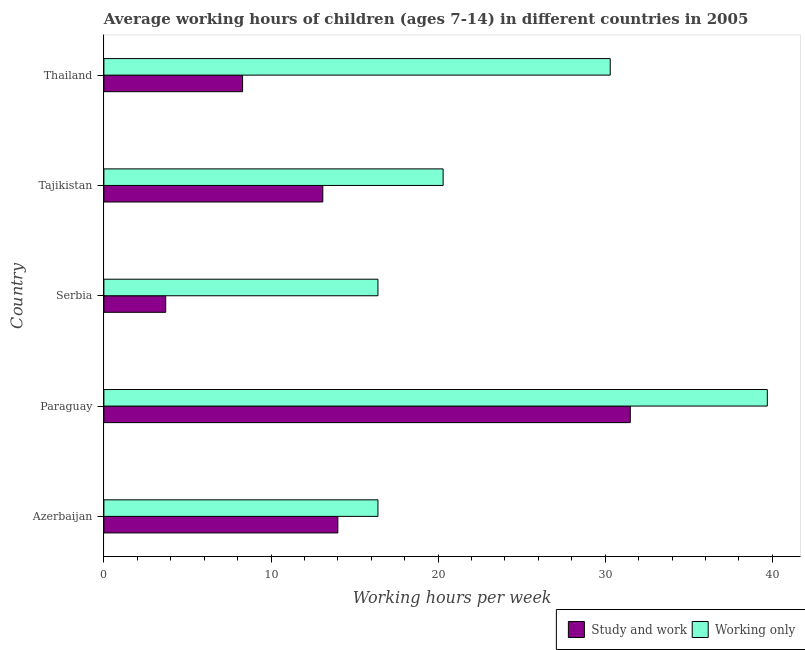How many different coloured bars are there?
Your answer should be compact. 2. Are the number of bars on each tick of the Y-axis equal?
Give a very brief answer. Yes. What is the label of the 4th group of bars from the top?
Provide a short and direct response. Paraguay. In how many cases, is the number of bars for a given country not equal to the number of legend labels?
Ensure brevity in your answer.  0. What is the average working hour of children involved in only work in Thailand?
Offer a very short reply. 30.3. Across all countries, what is the maximum average working hour of children involved in only work?
Make the answer very short. 39.7. In which country was the average working hour of children involved in study and work maximum?
Ensure brevity in your answer.  Paraguay. In which country was the average working hour of children involved in only work minimum?
Offer a terse response. Azerbaijan. What is the total average working hour of children involved in only work in the graph?
Keep it short and to the point. 123.1. What is the difference between the average working hour of children involved in only work in Paraguay and the average working hour of children involved in study and work in Tajikistan?
Make the answer very short. 26.6. What is the average average working hour of children involved in study and work per country?
Ensure brevity in your answer.  14.12. What is the ratio of the average working hour of children involved in study and work in Azerbaijan to that in Tajikistan?
Your response must be concise. 1.07. Is the average working hour of children involved in study and work in Serbia less than that in Tajikistan?
Ensure brevity in your answer.  Yes. Is the difference between the average working hour of children involved in study and work in Paraguay and Thailand greater than the difference between the average working hour of children involved in only work in Paraguay and Thailand?
Your answer should be compact. Yes. What is the difference between the highest and the second highest average working hour of children involved in study and work?
Offer a terse response. 17.5. What is the difference between the highest and the lowest average working hour of children involved in only work?
Offer a very short reply. 23.3. In how many countries, is the average working hour of children involved in study and work greater than the average average working hour of children involved in study and work taken over all countries?
Provide a succinct answer. 1. What does the 1st bar from the top in Azerbaijan represents?
Offer a very short reply. Working only. What does the 1st bar from the bottom in Paraguay represents?
Provide a short and direct response. Study and work. Are all the bars in the graph horizontal?
Provide a short and direct response. Yes. What is the difference between two consecutive major ticks on the X-axis?
Ensure brevity in your answer.  10. Are the values on the major ticks of X-axis written in scientific E-notation?
Your response must be concise. No. Does the graph contain any zero values?
Provide a succinct answer. No. How many legend labels are there?
Keep it short and to the point. 2. How are the legend labels stacked?
Your answer should be very brief. Horizontal. What is the title of the graph?
Offer a terse response. Average working hours of children (ages 7-14) in different countries in 2005. What is the label or title of the X-axis?
Offer a terse response. Working hours per week. What is the label or title of the Y-axis?
Your response must be concise. Country. What is the Working hours per week of Study and work in Azerbaijan?
Offer a terse response. 14. What is the Working hours per week of Working only in Azerbaijan?
Make the answer very short. 16.4. What is the Working hours per week of Study and work in Paraguay?
Give a very brief answer. 31.5. What is the Working hours per week in Working only in Paraguay?
Make the answer very short. 39.7. What is the Working hours per week in Study and work in Tajikistan?
Your response must be concise. 13.1. What is the Working hours per week in Working only in Tajikistan?
Provide a succinct answer. 20.3. What is the Working hours per week of Working only in Thailand?
Your answer should be compact. 30.3. Across all countries, what is the maximum Working hours per week in Study and work?
Your answer should be compact. 31.5. Across all countries, what is the maximum Working hours per week of Working only?
Offer a terse response. 39.7. Across all countries, what is the minimum Working hours per week in Study and work?
Your answer should be very brief. 3.7. What is the total Working hours per week in Study and work in the graph?
Your response must be concise. 70.6. What is the total Working hours per week of Working only in the graph?
Provide a succinct answer. 123.1. What is the difference between the Working hours per week of Study and work in Azerbaijan and that in Paraguay?
Provide a succinct answer. -17.5. What is the difference between the Working hours per week in Working only in Azerbaijan and that in Paraguay?
Your response must be concise. -23.3. What is the difference between the Working hours per week in Working only in Azerbaijan and that in Serbia?
Your response must be concise. 0. What is the difference between the Working hours per week in Working only in Azerbaijan and that in Tajikistan?
Provide a short and direct response. -3.9. What is the difference between the Working hours per week in Study and work in Paraguay and that in Serbia?
Your response must be concise. 27.8. What is the difference between the Working hours per week in Working only in Paraguay and that in Serbia?
Your answer should be compact. 23.3. What is the difference between the Working hours per week of Working only in Paraguay and that in Tajikistan?
Your response must be concise. 19.4. What is the difference between the Working hours per week of Study and work in Paraguay and that in Thailand?
Keep it short and to the point. 23.2. What is the difference between the Working hours per week of Working only in Paraguay and that in Thailand?
Your answer should be compact. 9.4. What is the difference between the Working hours per week of Working only in Serbia and that in Tajikistan?
Provide a short and direct response. -3.9. What is the difference between the Working hours per week of Working only in Serbia and that in Thailand?
Your answer should be compact. -13.9. What is the difference between the Working hours per week in Study and work in Tajikistan and that in Thailand?
Provide a succinct answer. 4.8. What is the difference between the Working hours per week of Working only in Tajikistan and that in Thailand?
Offer a terse response. -10. What is the difference between the Working hours per week in Study and work in Azerbaijan and the Working hours per week in Working only in Paraguay?
Make the answer very short. -25.7. What is the difference between the Working hours per week in Study and work in Azerbaijan and the Working hours per week in Working only in Tajikistan?
Give a very brief answer. -6.3. What is the difference between the Working hours per week in Study and work in Azerbaijan and the Working hours per week in Working only in Thailand?
Give a very brief answer. -16.3. What is the difference between the Working hours per week of Study and work in Serbia and the Working hours per week of Working only in Tajikistan?
Give a very brief answer. -16.6. What is the difference between the Working hours per week of Study and work in Serbia and the Working hours per week of Working only in Thailand?
Your answer should be compact. -26.6. What is the difference between the Working hours per week of Study and work in Tajikistan and the Working hours per week of Working only in Thailand?
Keep it short and to the point. -17.2. What is the average Working hours per week in Study and work per country?
Provide a succinct answer. 14.12. What is the average Working hours per week in Working only per country?
Provide a short and direct response. 24.62. What is the ratio of the Working hours per week of Study and work in Azerbaijan to that in Paraguay?
Keep it short and to the point. 0.44. What is the ratio of the Working hours per week of Working only in Azerbaijan to that in Paraguay?
Your response must be concise. 0.41. What is the ratio of the Working hours per week of Study and work in Azerbaijan to that in Serbia?
Your response must be concise. 3.78. What is the ratio of the Working hours per week in Study and work in Azerbaijan to that in Tajikistan?
Keep it short and to the point. 1.07. What is the ratio of the Working hours per week in Working only in Azerbaijan to that in Tajikistan?
Keep it short and to the point. 0.81. What is the ratio of the Working hours per week of Study and work in Azerbaijan to that in Thailand?
Your answer should be very brief. 1.69. What is the ratio of the Working hours per week of Working only in Azerbaijan to that in Thailand?
Provide a short and direct response. 0.54. What is the ratio of the Working hours per week in Study and work in Paraguay to that in Serbia?
Your response must be concise. 8.51. What is the ratio of the Working hours per week in Working only in Paraguay to that in Serbia?
Ensure brevity in your answer.  2.42. What is the ratio of the Working hours per week of Study and work in Paraguay to that in Tajikistan?
Your response must be concise. 2.4. What is the ratio of the Working hours per week in Working only in Paraguay to that in Tajikistan?
Ensure brevity in your answer.  1.96. What is the ratio of the Working hours per week of Study and work in Paraguay to that in Thailand?
Your response must be concise. 3.8. What is the ratio of the Working hours per week of Working only in Paraguay to that in Thailand?
Ensure brevity in your answer.  1.31. What is the ratio of the Working hours per week of Study and work in Serbia to that in Tajikistan?
Provide a succinct answer. 0.28. What is the ratio of the Working hours per week in Working only in Serbia to that in Tajikistan?
Provide a short and direct response. 0.81. What is the ratio of the Working hours per week in Study and work in Serbia to that in Thailand?
Provide a succinct answer. 0.45. What is the ratio of the Working hours per week in Working only in Serbia to that in Thailand?
Provide a short and direct response. 0.54. What is the ratio of the Working hours per week of Study and work in Tajikistan to that in Thailand?
Ensure brevity in your answer.  1.58. What is the ratio of the Working hours per week in Working only in Tajikistan to that in Thailand?
Keep it short and to the point. 0.67. What is the difference between the highest and the second highest Working hours per week in Study and work?
Make the answer very short. 17.5. What is the difference between the highest and the second highest Working hours per week in Working only?
Provide a succinct answer. 9.4. What is the difference between the highest and the lowest Working hours per week in Study and work?
Offer a very short reply. 27.8. What is the difference between the highest and the lowest Working hours per week in Working only?
Offer a very short reply. 23.3. 